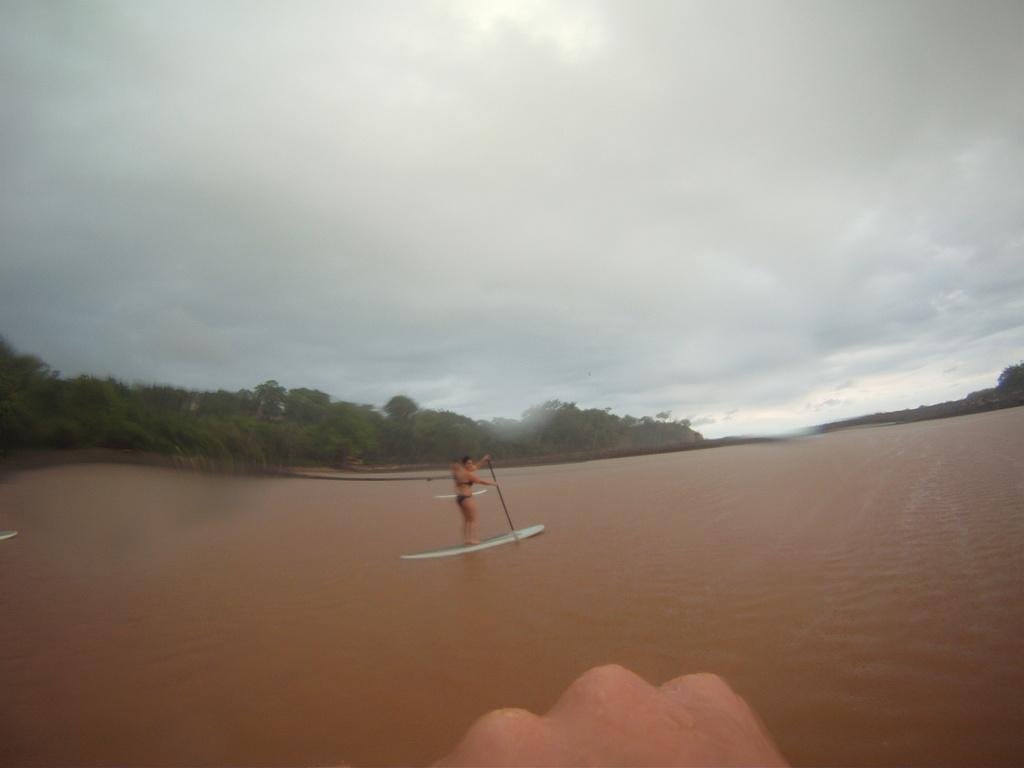What is the main subject of the image? There is a person in the image. What is the person doing in the image? The person is standing on a surfboard. What is the person holding in the image? The person is holding a stick. Where is the surfboard located in the image? The surfboard is on the water. What can be seen in the background of the image? There are trees and the sky visible in the background of the image. What is the condition of the sky in the image? Clouds are present in the sky. What type of disease is the person suffering from in the image? There is no indication in the image that the person is suffering from any disease. What event is the person attending in the image? There is no event depicted in the image; it shows a person standing on a surfboard on the water. 